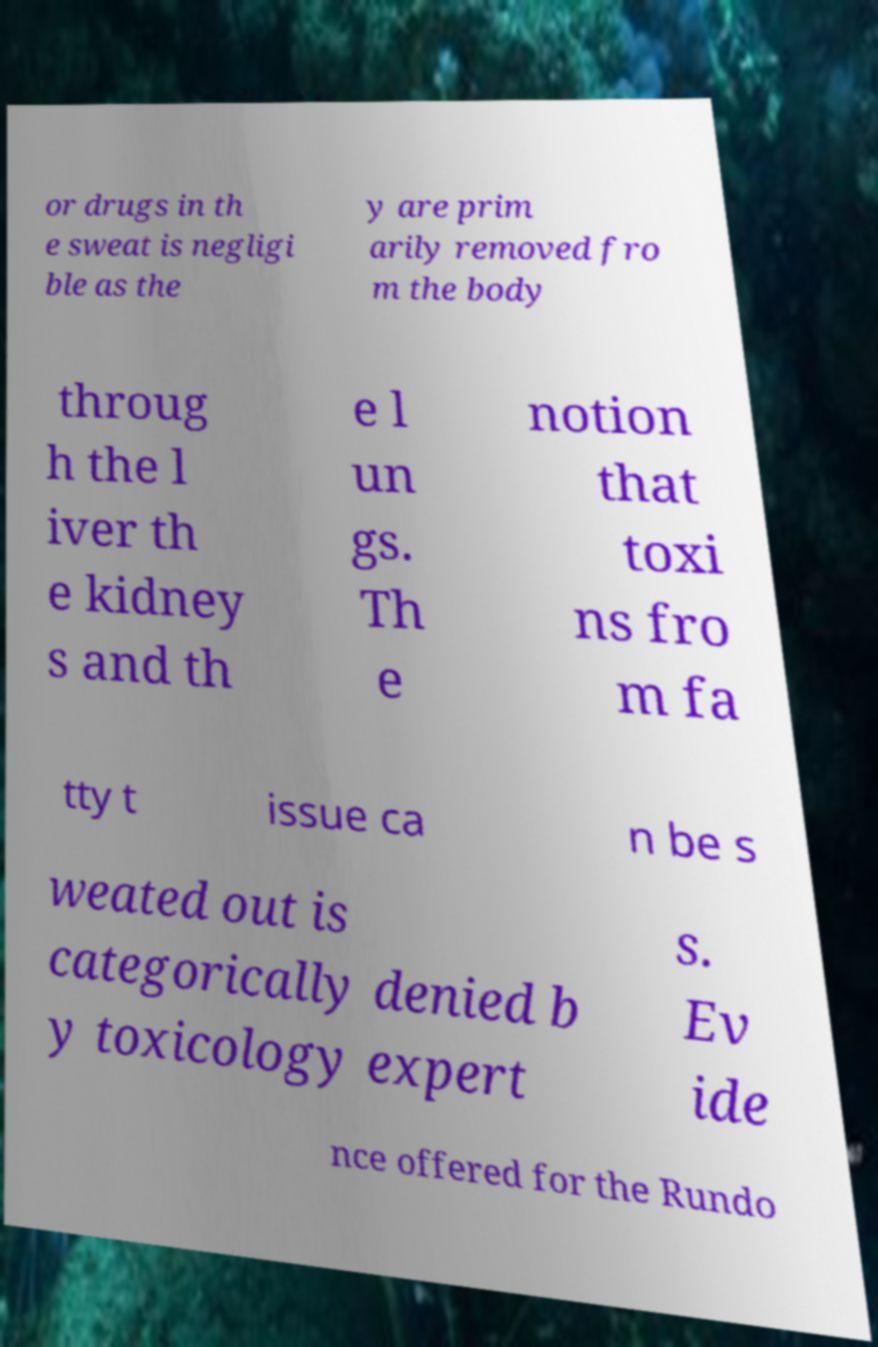Could you extract and type out the text from this image? or drugs in th e sweat is negligi ble as the y are prim arily removed fro m the body throug h the l iver th e kidney s and th e l un gs. Th e notion that toxi ns fro m fa tty t issue ca n be s weated out is categorically denied b y toxicology expert s. Ev ide nce offered for the Rundo 